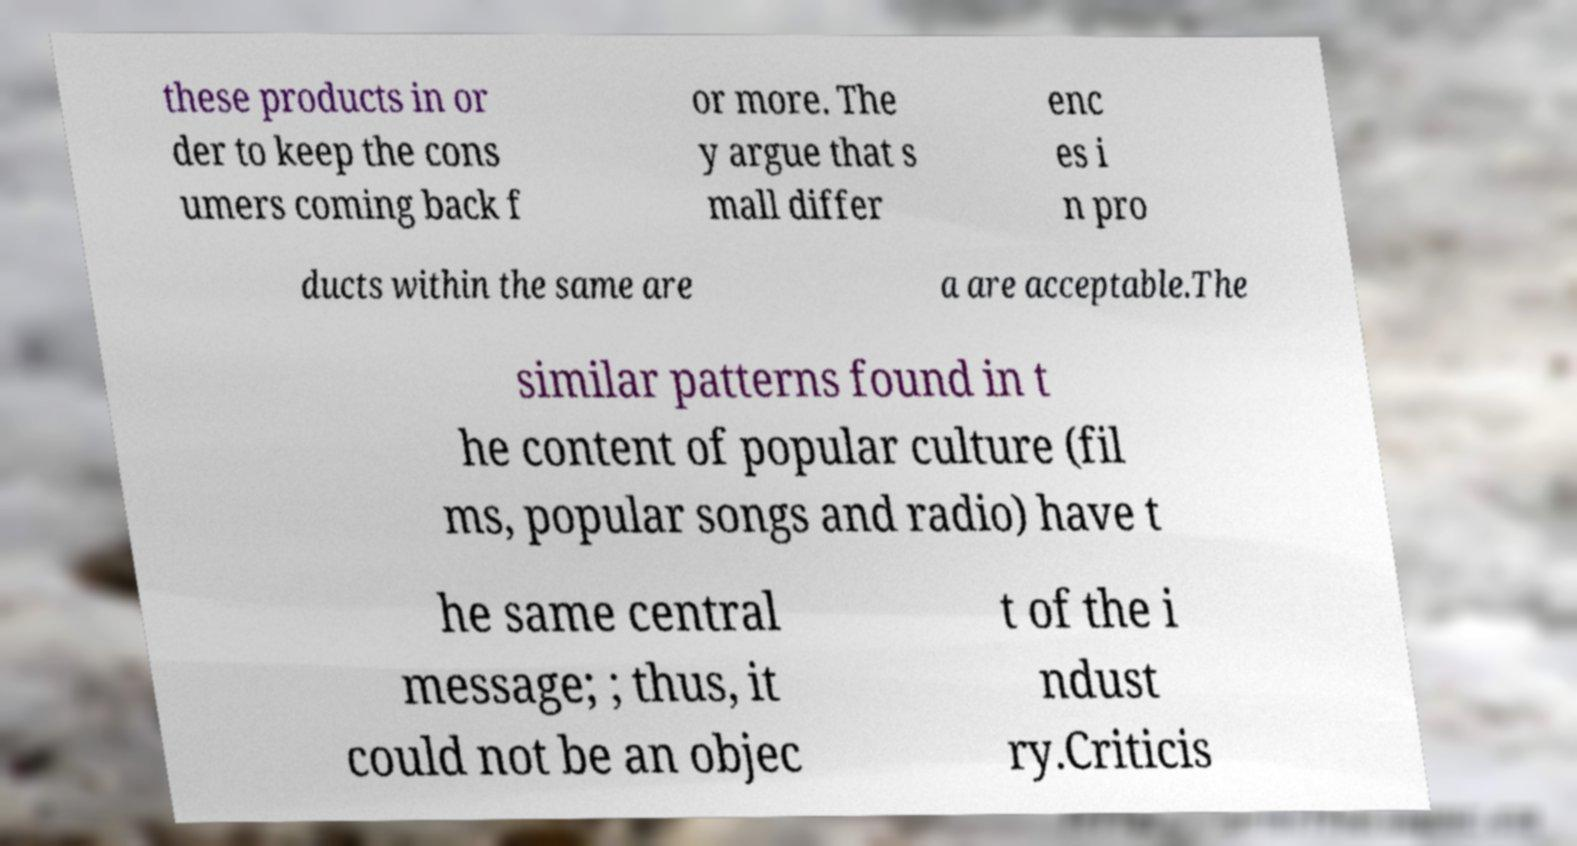I need the written content from this picture converted into text. Can you do that? these products in or der to keep the cons umers coming back f or more. The y argue that s mall differ enc es i n pro ducts within the same are a are acceptable.The similar patterns found in t he content of popular culture (fil ms, popular songs and radio) have t he same central message; ; thus, it could not be an objec t of the i ndust ry.Criticis 